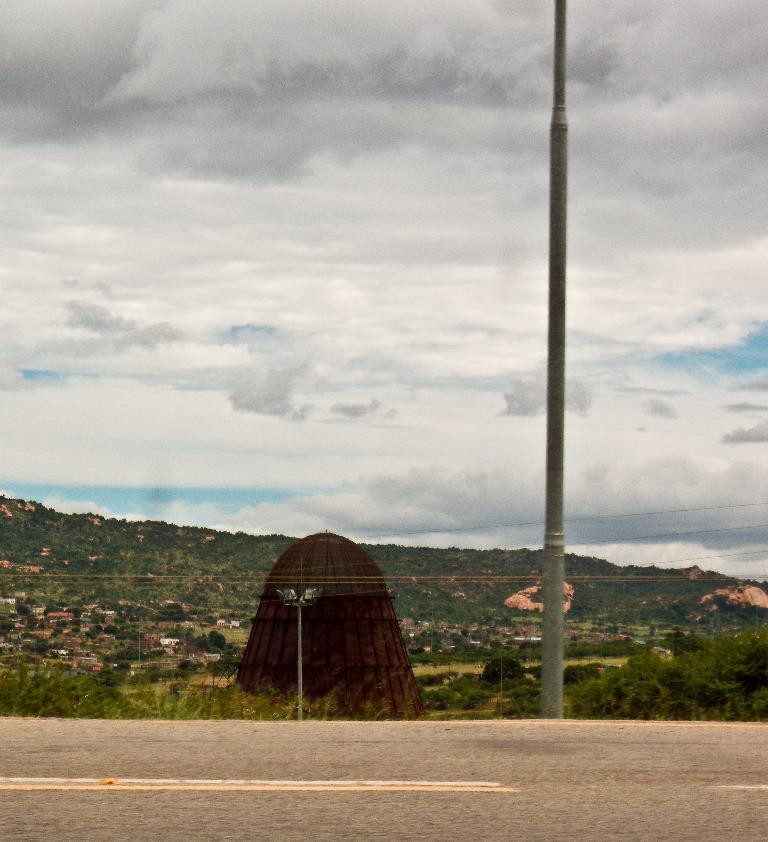What is located at the bottom of the image? There is a road at the bottom of the image. What can be seen in the image besides the road? There is a pole, grass, a light pole, electrical wires, bricks, houses, trees, and clouds visible in the image. Can you describe the pole in the image? There is a pole in the image, and it is also a light pole. What type of vegetation is present in the background of the image? Trees are present in the background of the image. What is the condition of the sky in the image? The sky contains clouds in the image. Can you see the moon in the image? No, the moon is not visible in the image. Is there a railway track in the image? No, there is no railway track present in the image. 